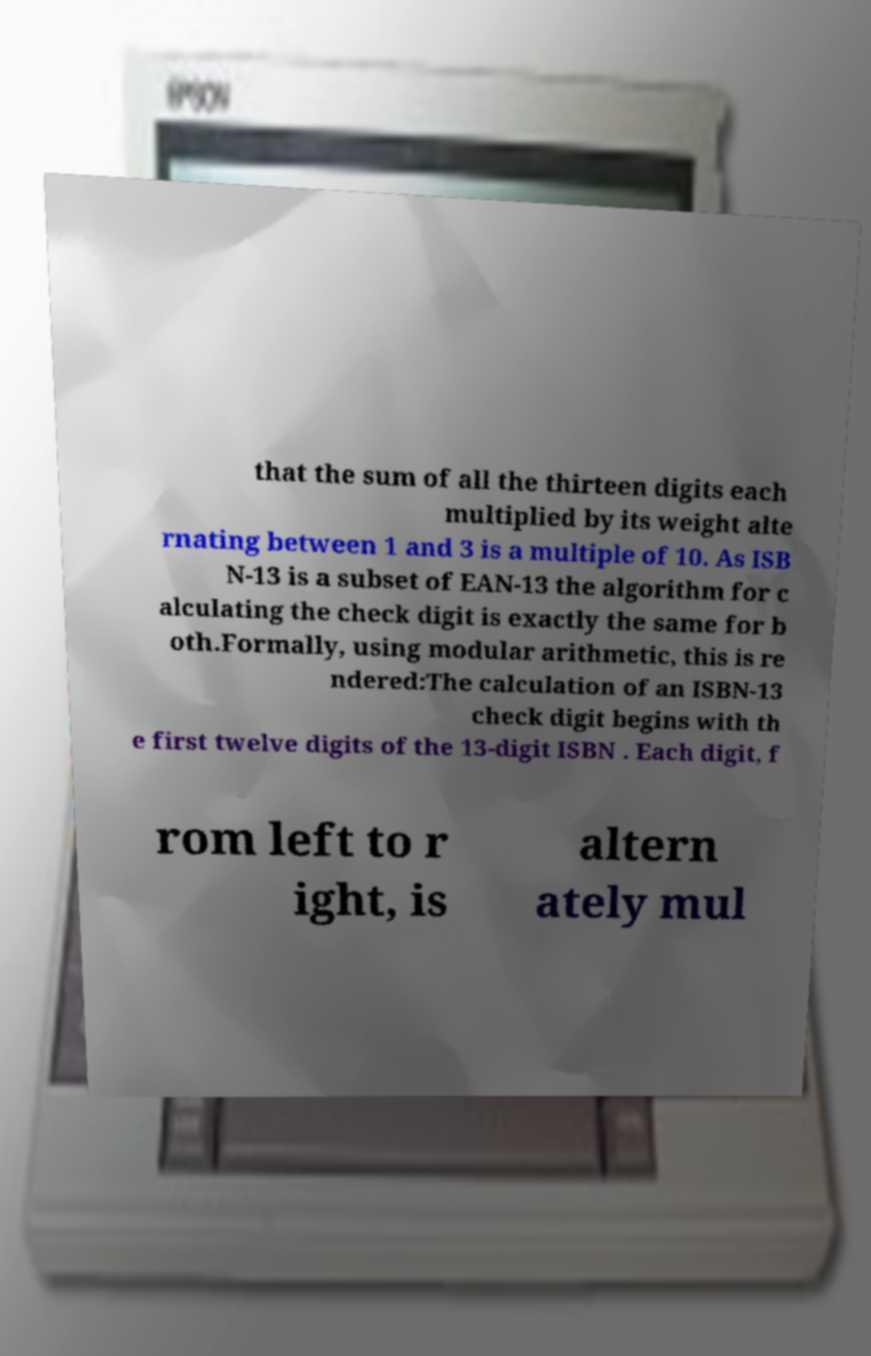Please identify and transcribe the text found in this image. that the sum of all the thirteen digits each multiplied by its weight alte rnating between 1 and 3 is a multiple of 10. As ISB N-13 is a subset of EAN-13 the algorithm for c alculating the check digit is exactly the same for b oth.Formally, using modular arithmetic, this is re ndered:The calculation of an ISBN-13 check digit begins with th e first twelve digits of the 13-digit ISBN . Each digit, f rom left to r ight, is altern ately mul 